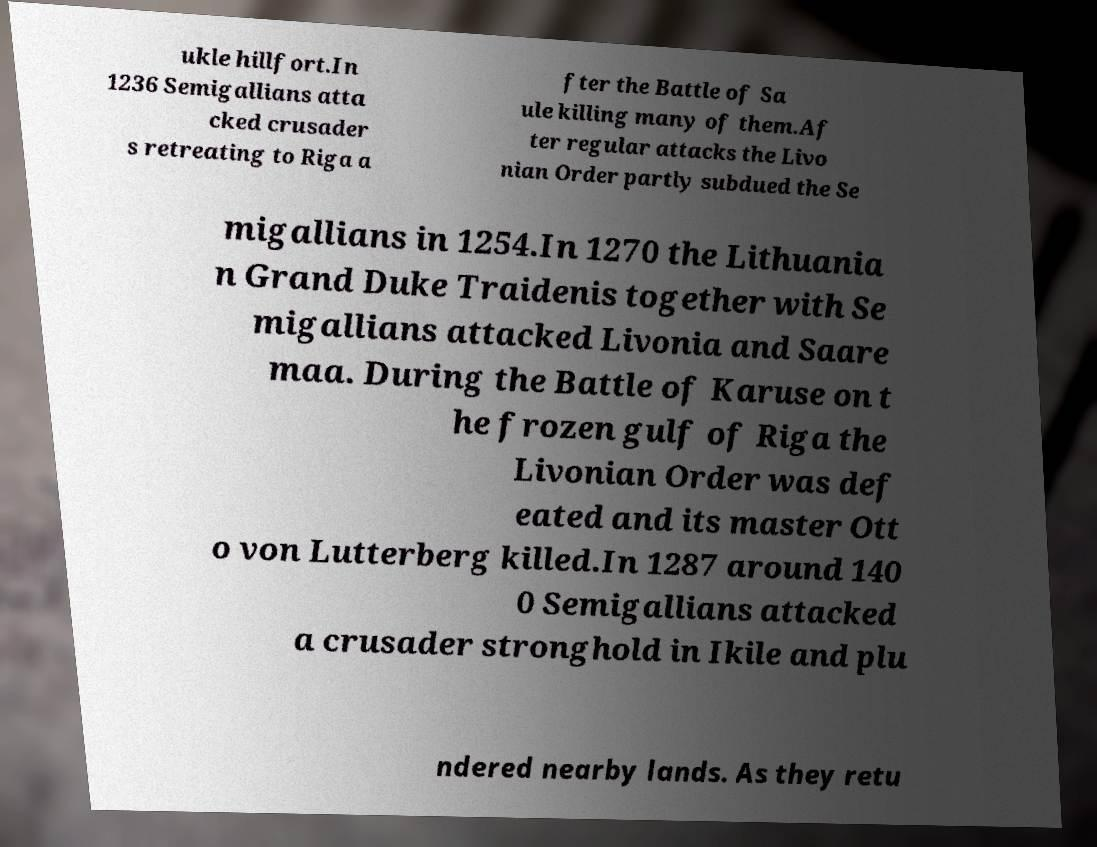Please read and relay the text visible in this image. What does it say? ukle hillfort.In 1236 Semigallians atta cked crusader s retreating to Riga a fter the Battle of Sa ule killing many of them.Af ter regular attacks the Livo nian Order partly subdued the Se migallians in 1254.In 1270 the Lithuania n Grand Duke Traidenis together with Se migallians attacked Livonia and Saare maa. During the Battle of Karuse on t he frozen gulf of Riga the Livonian Order was def eated and its master Ott o von Lutterberg killed.In 1287 around 140 0 Semigallians attacked a crusader stronghold in Ikile and plu ndered nearby lands. As they retu 